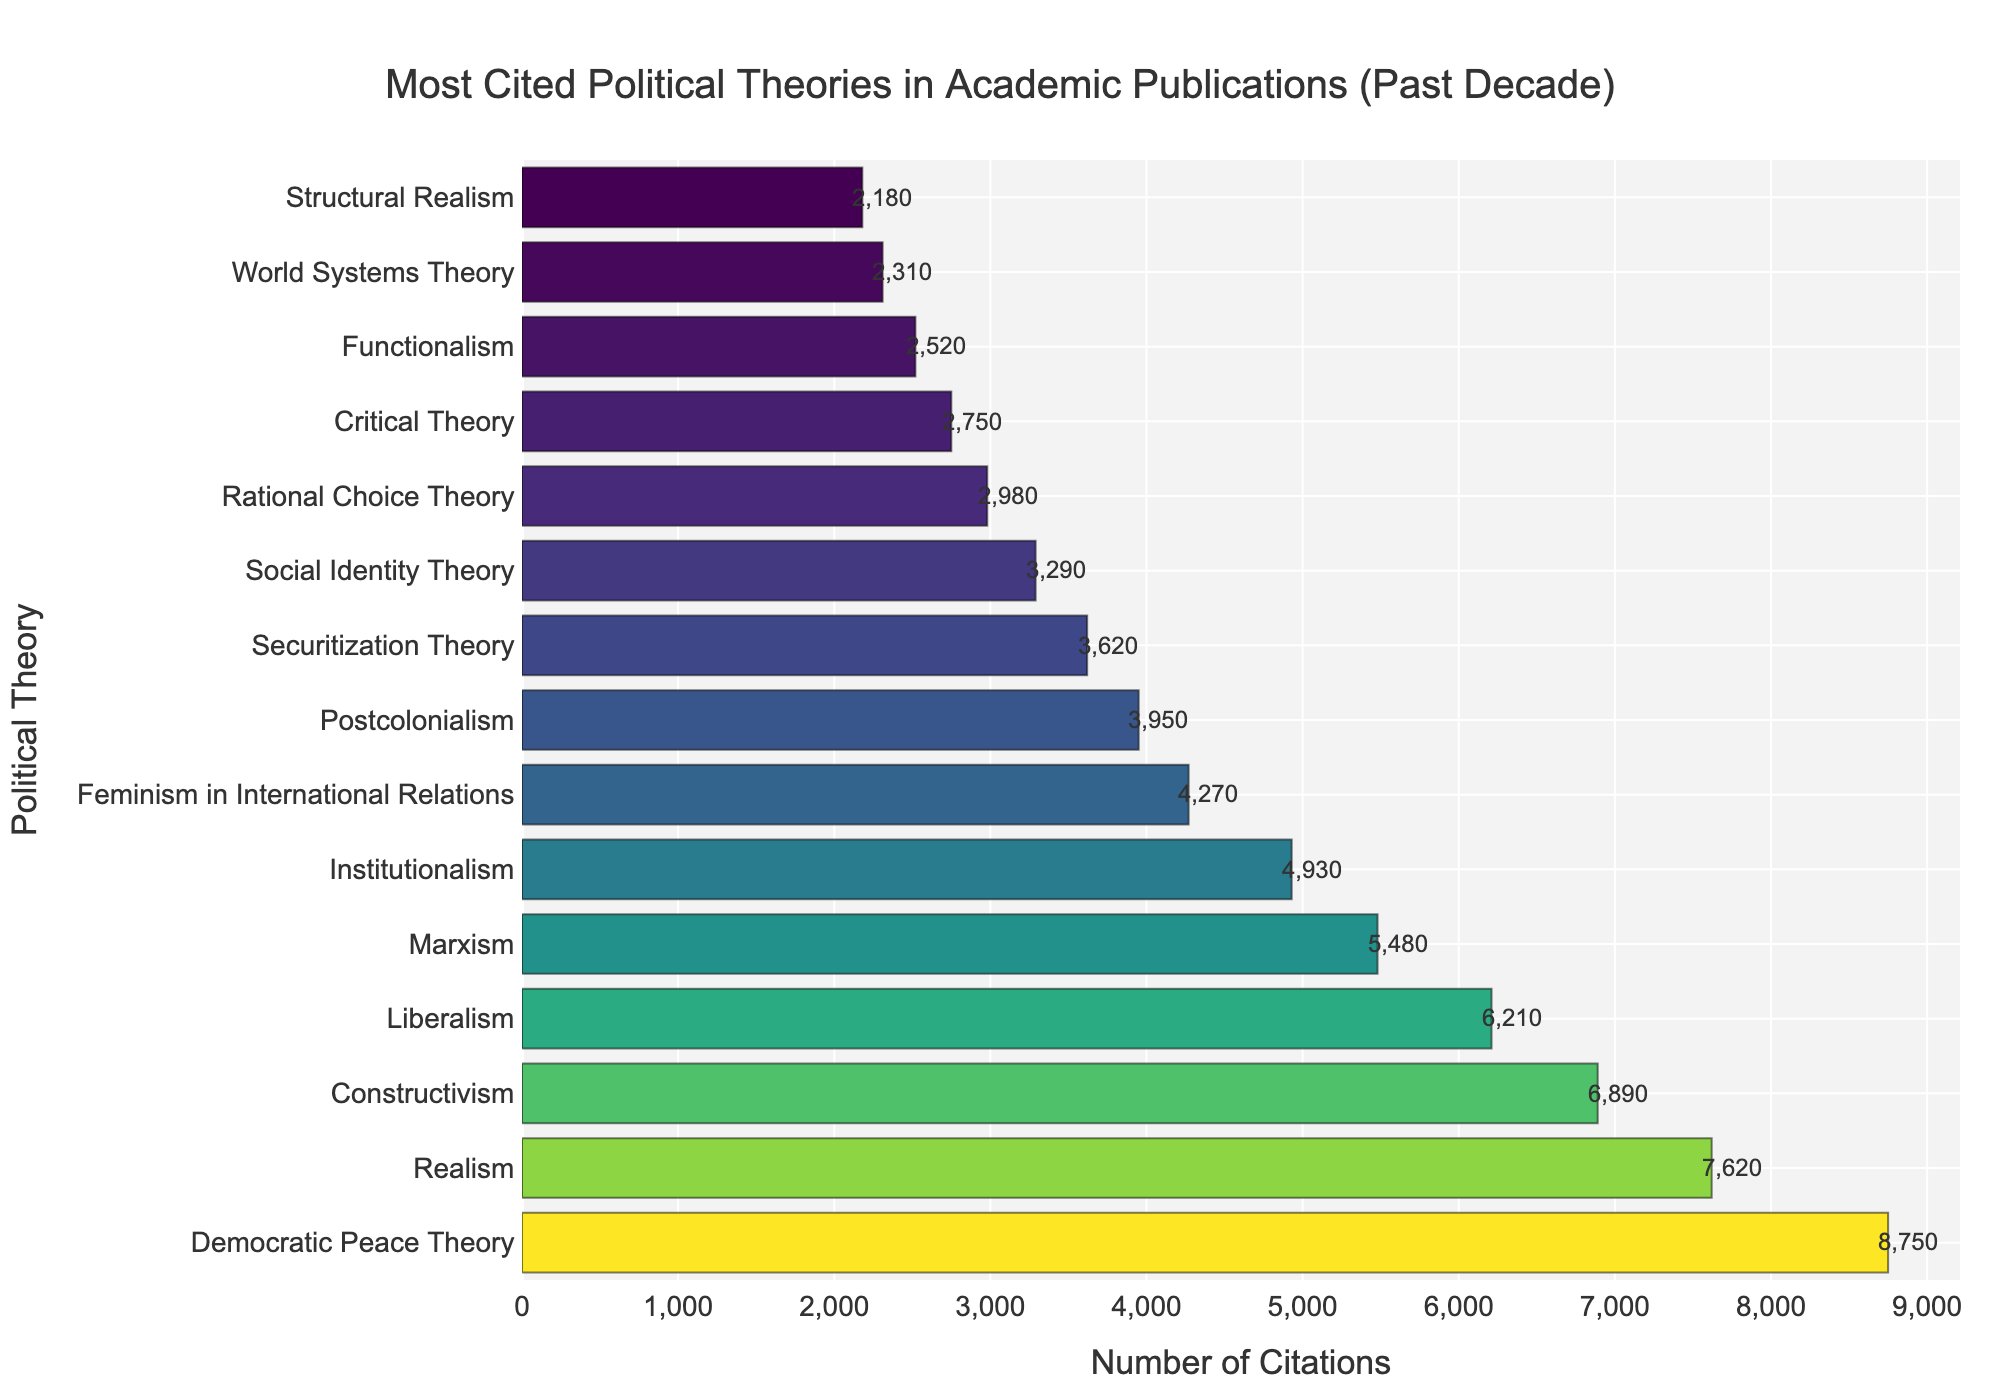Which political theory has the highest number of citations? Look at the top of the bar chart where the longest bar is located. The label at the top will indicate the theory with the highest citations.
Answer: Democratic Peace Theory How many more citations does Realism have compared to Feminism in International Relations? Find the citation numbers for Realism (7620) and Feminism in International Relations (4270) and subtract the smaller number from the larger number: 7620 - 4270.
Answer: 3350 Which theory has fewer citations, Liberalism or Constructivism? Compare the length of the bars corresponding to Liberalism (6210) and Constructivism (6890). The shorter bar represents the theory with fewer citations.
Answer: Liberalism What's the total number of citations for the top three theories? Sum the citation numbers for the top three theories: Democratic Peace Theory (8750), Realism (7620), and Constructivism (6890): 8750 + 7620 + 6890.
Answer: 23260 Which theory has the shortest bar, indicating the fewest citations? Look at the bottom of the bar chart where the shortest bar is located. The label at the bottom will indicate the theory with the fewest citations.
Answer: Structural Realism What is the average number of citations among the theories with less than 4000 citations? Identify the theories with citations below 4000: Postcolonialism (3950), Securitization Theory (3620), Social Identity Theory (3290), Rational Choice Theory (2980), Critical Theory (2750), Functionalism (2520), and Structural Realism (2180). Sum these citations and divide by the number of theories: (3950 + 3620 + 3290 + 2980 + 2750 + 2520 + 2180) / 7.
Answer: 3041.43 How many theories have more citations than Marxism? Identify the citation number for Marxism (5480). Count the number of bars with citations higher than 5480: Democratic Peace Theory, Realism, Constructivism, and Liberalism.
Answer: 4 By how much does the citation count for Institutionalism exceed that of Critical Theory? Find the citation numbers for Institutionalism (4930) and Critical Theory (2750) and subtract the smaller number from the larger number: 4930 - 2750.
Answer: 2180 